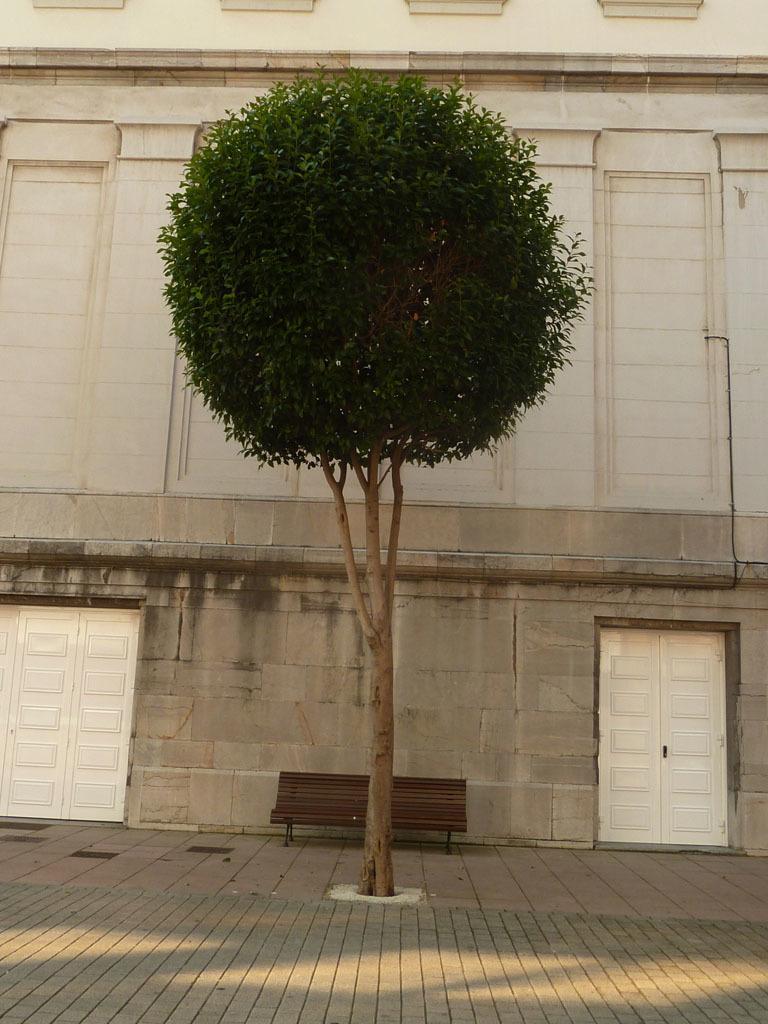How would you summarize this image in a sentence or two? There is a tree on a sidewalk. In the back there is a bench. Near to bench there is a building with doors. 